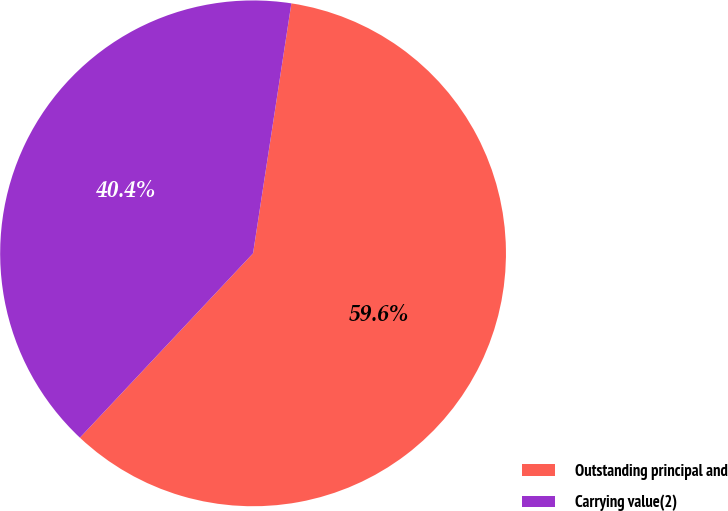Convert chart to OTSL. <chart><loc_0><loc_0><loc_500><loc_500><pie_chart><fcel>Outstanding principal and<fcel>Carrying value(2)<nl><fcel>59.58%<fcel>40.42%<nl></chart> 